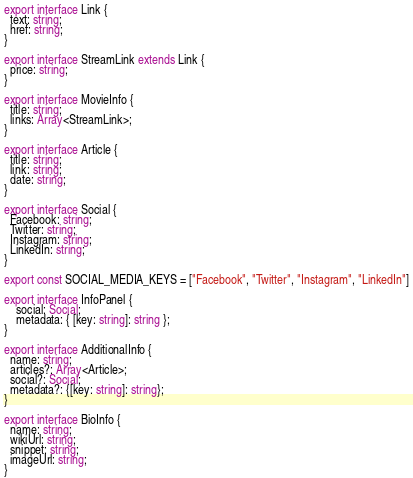Convert code to text. <code><loc_0><loc_0><loc_500><loc_500><_TypeScript_>export interface Link {
  text: string;
  href: string;
}

export interface StreamLink extends Link {
  price: string;
}

export interface MovieInfo {
  title: string;
  links: Array<StreamLink>;
}

export interface Article {
  title: string;
  link: string;
  date: string;
}

export interface Social {
  Facebook: string;
  Twitter: string;
  Instagram: string;
  LinkedIn: string;
}

export const SOCIAL_MEDIA_KEYS = ["Facebook", "Twitter", "Instagram", "LinkedIn"]

export interface InfoPanel {
    social: Social;
    metadata: { [key: string]: string };
}

export interface AdditionalInfo {
  name: string;
  articles?: Array<Article>;
  social?: Social;
  metadata?: {[key: string]: string};
}

export interface BioInfo {
  name: string;
  wikiUrl: string;
  snippet: string;
  imageUrl: string;
}
</code> 